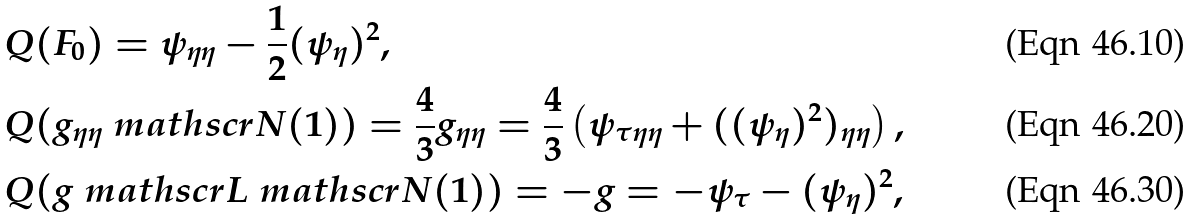Convert formula to latex. <formula><loc_0><loc_0><loc_500><loc_500>& Q ( { F } _ { 0 } ) = \psi _ { \eta \eta } - \frac { 1 } { 2 } ( \psi _ { \eta } ) ^ { 2 } , \\ & Q ( g _ { \eta \eta } { \ m a t h s c r N } ( 1 ) ) = \frac { 4 } { 3 } g _ { \eta \eta } = \frac { 4 } { 3 } \left ( \psi _ { \tau \eta \eta } + ( ( \psi _ { \eta } ) ^ { 2 } ) _ { \eta \eta } \right ) , \\ & Q ( g { \ m a t h s c r L } { \ m a t h s c r N } ( 1 ) ) = - g = - \psi _ { \tau } - ( \psi _ { \eta } ) ^ { 2 } ,</formula> 